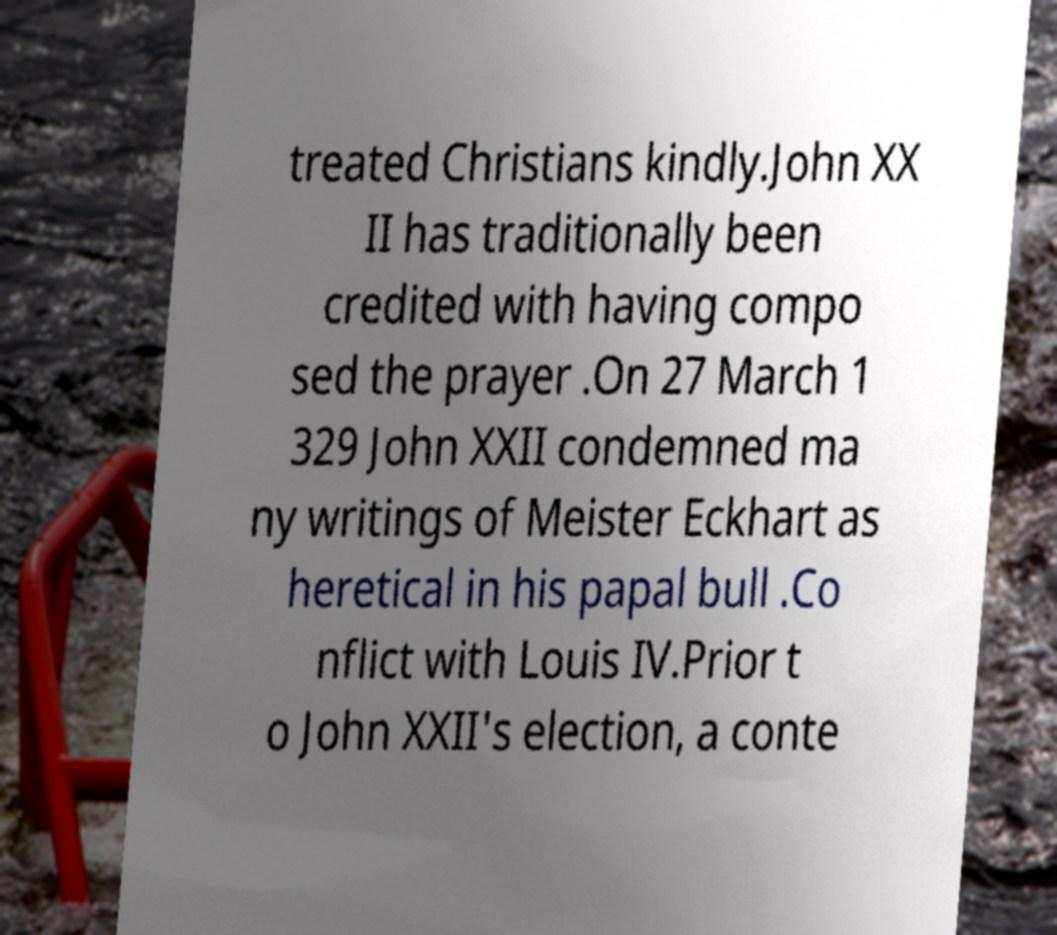Please identify and transcribe the text found in this image. treated Christians kindly.John XX II has traditionally been credited with having compo sed the prayer .On 27 March 1 329 John XXII condemned ma ny writings of Meister Eckhart as heretical in his papal bull .Co nflict with Louis IV.Prior t o John XXII's election, a conte 